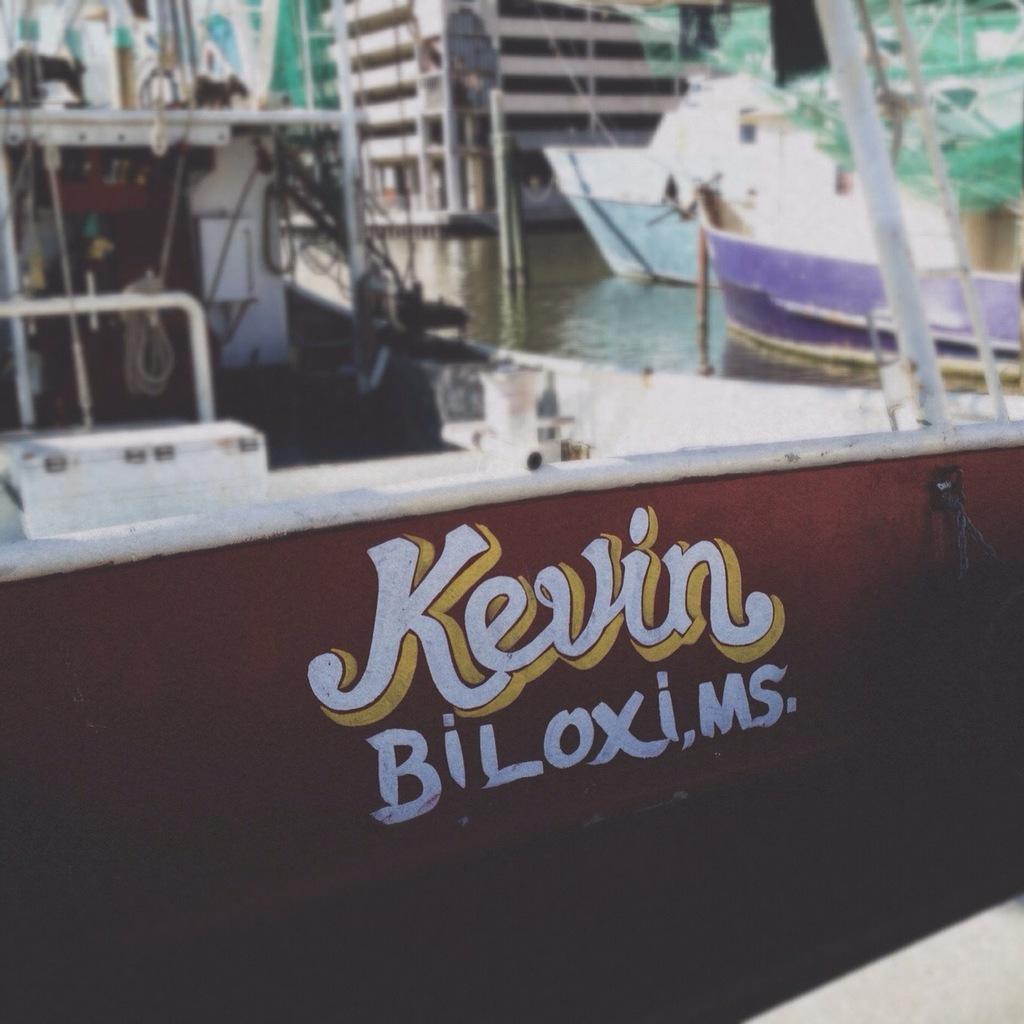What is the main subject of the image? There is a painting in the image. What can be found within the painting? The painting contains texts. What is the color of the surface on which the painting is placed? The painting is on a brown color surface. What can be seen in the background of the image? There are boats on water and a building in the background of the image. What sense does the stranger use to appreciate the painting in the image? There is no stranger present in the image. Can you tell me the name of the street where the painting is located? There is no mention of a street in the image. 